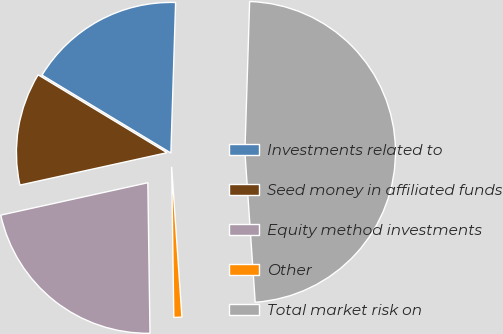Convert chart to OTSL. <chart><loc_0><loc_0><loc_500><loc_500><pie_chart><fcel>Investments related to<fcel>Seed money in affiliated funds<fcel>Equity method investments<fcel>Other<fcel>Total market risk on<nl><fcel>16.85%<fcel>12.1%<fcel>21.78%<fcel>0.86%<fcel>48.41%<nl></chart> 